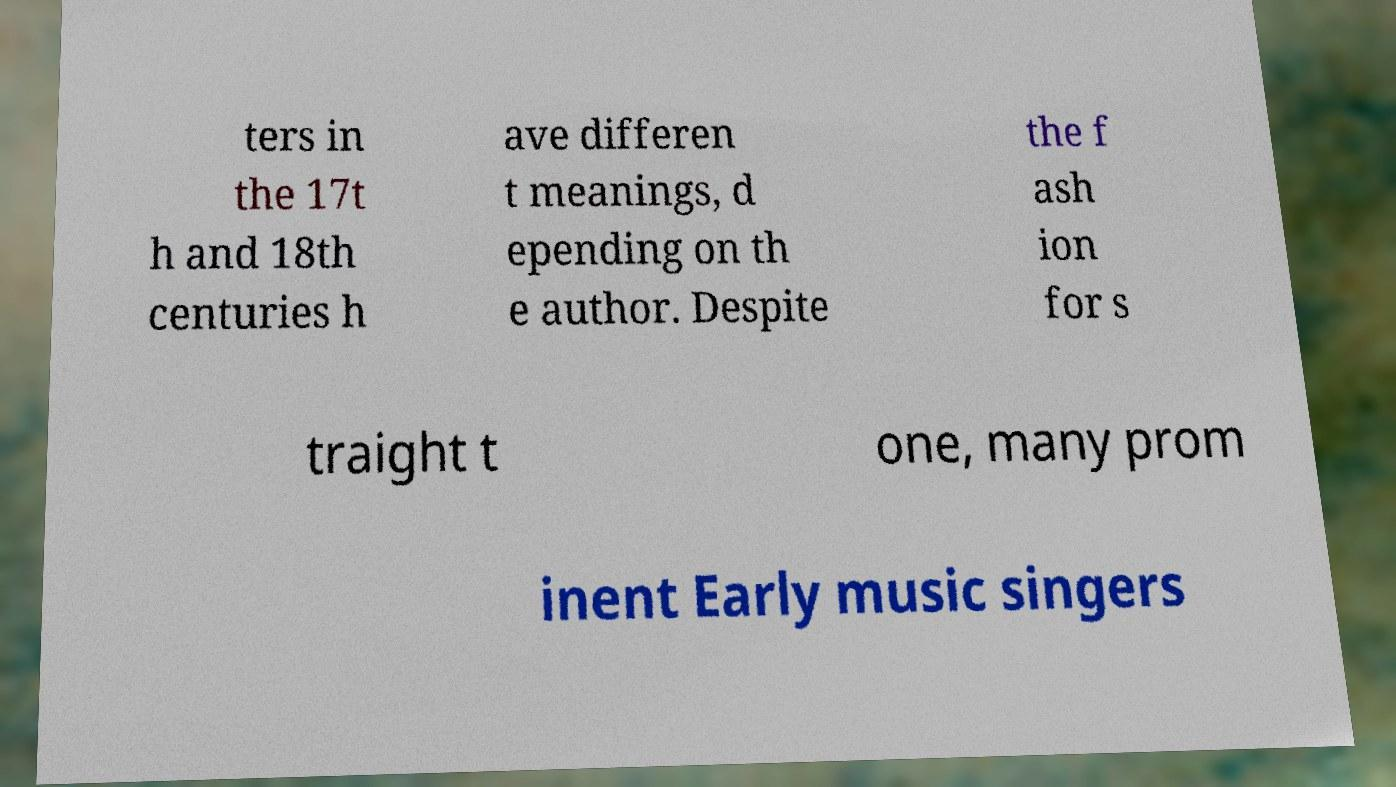There's text embedded in this image that I need extracted. Can you transcribe it verbatim? ters in the 17t h and 18th centuries h ave differen t meanings, d epending on th e author. Despite the f ash ion for s traight t one, many prom inent Early music singers 